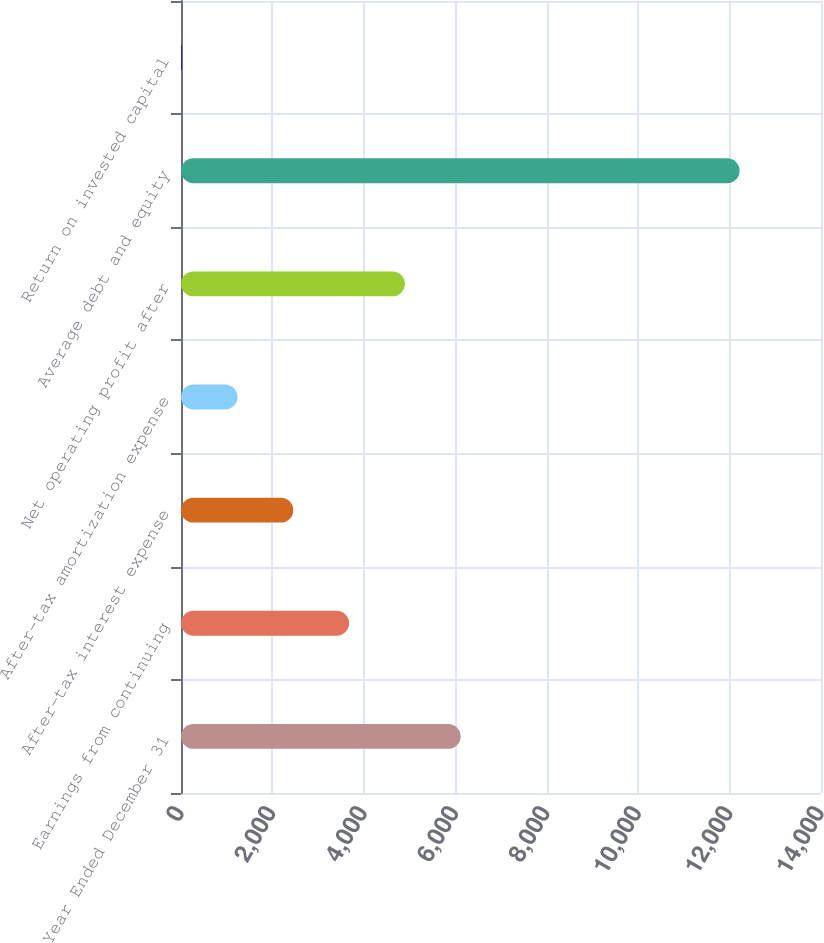Convert chart to OTSL. <chart><loc_0><loc_0><loc_500><loc_500><bar_chart><fcel>Year Ended December 31<fcel>Earnings from continuing<fcel>After-tax interest expense<fcel>After-tax amortization expense<fcel>Net operating profit after<fcel>Average debt and equity<fcel>Return on invested capital<nl><fcel>6117.8<fcel>3676.92<fcel>2456.48<fcel>1236.04<fcel>4897.36<fcel>12220<fcel>15.6<nl></chart> 